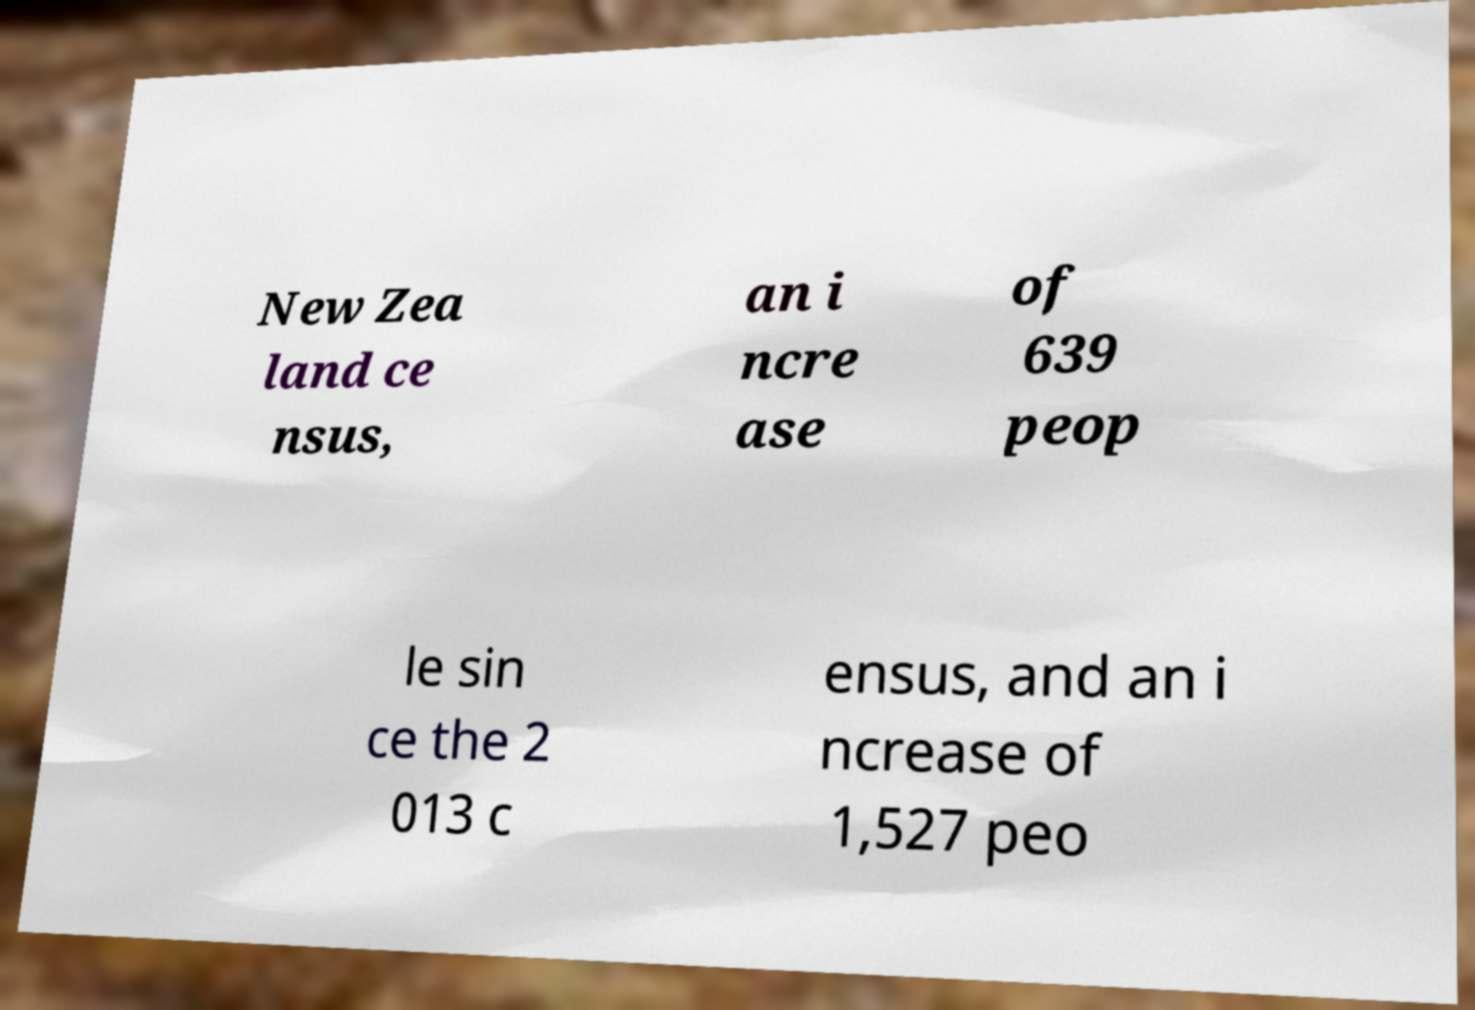What messages or text are displayed in this image? I need them in a readable, typed format. New Zea land ce nsus, an i ncre ase of 639 peop le sin ce the 2 013 c ensus, and an i ncrease of 1,527 peo 